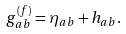<formula> <loc_0><loc_0><loc_500><loc_500>g _ { a b } ^ { ( f ) } = \eta _ { a b } + h _ { a b } .</formula> 